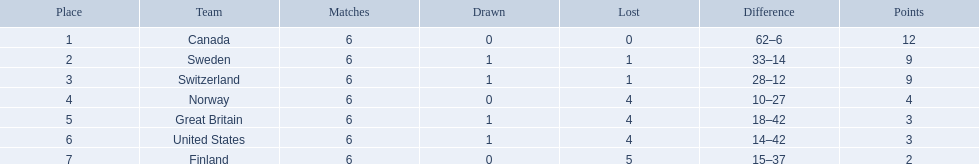What are the names of the countries? Canada, Sweden, Switzerland, Norway, Great Britain, United States, Finland. How many wins did switzerland have? 4. How many wins did great britain have? 1. Which country had more wins, great britain or switzerland? Switzerland. 